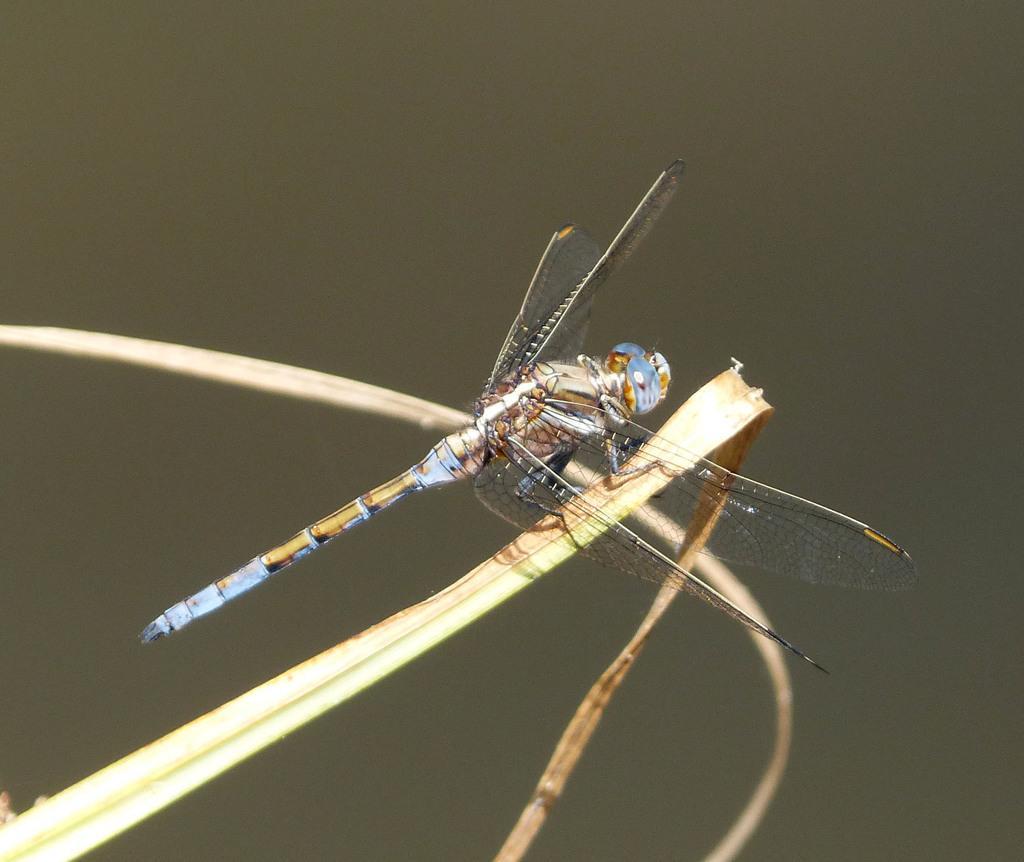How would you summarize this image in a sentence or two? In the center of the image there is a fly on grass. 